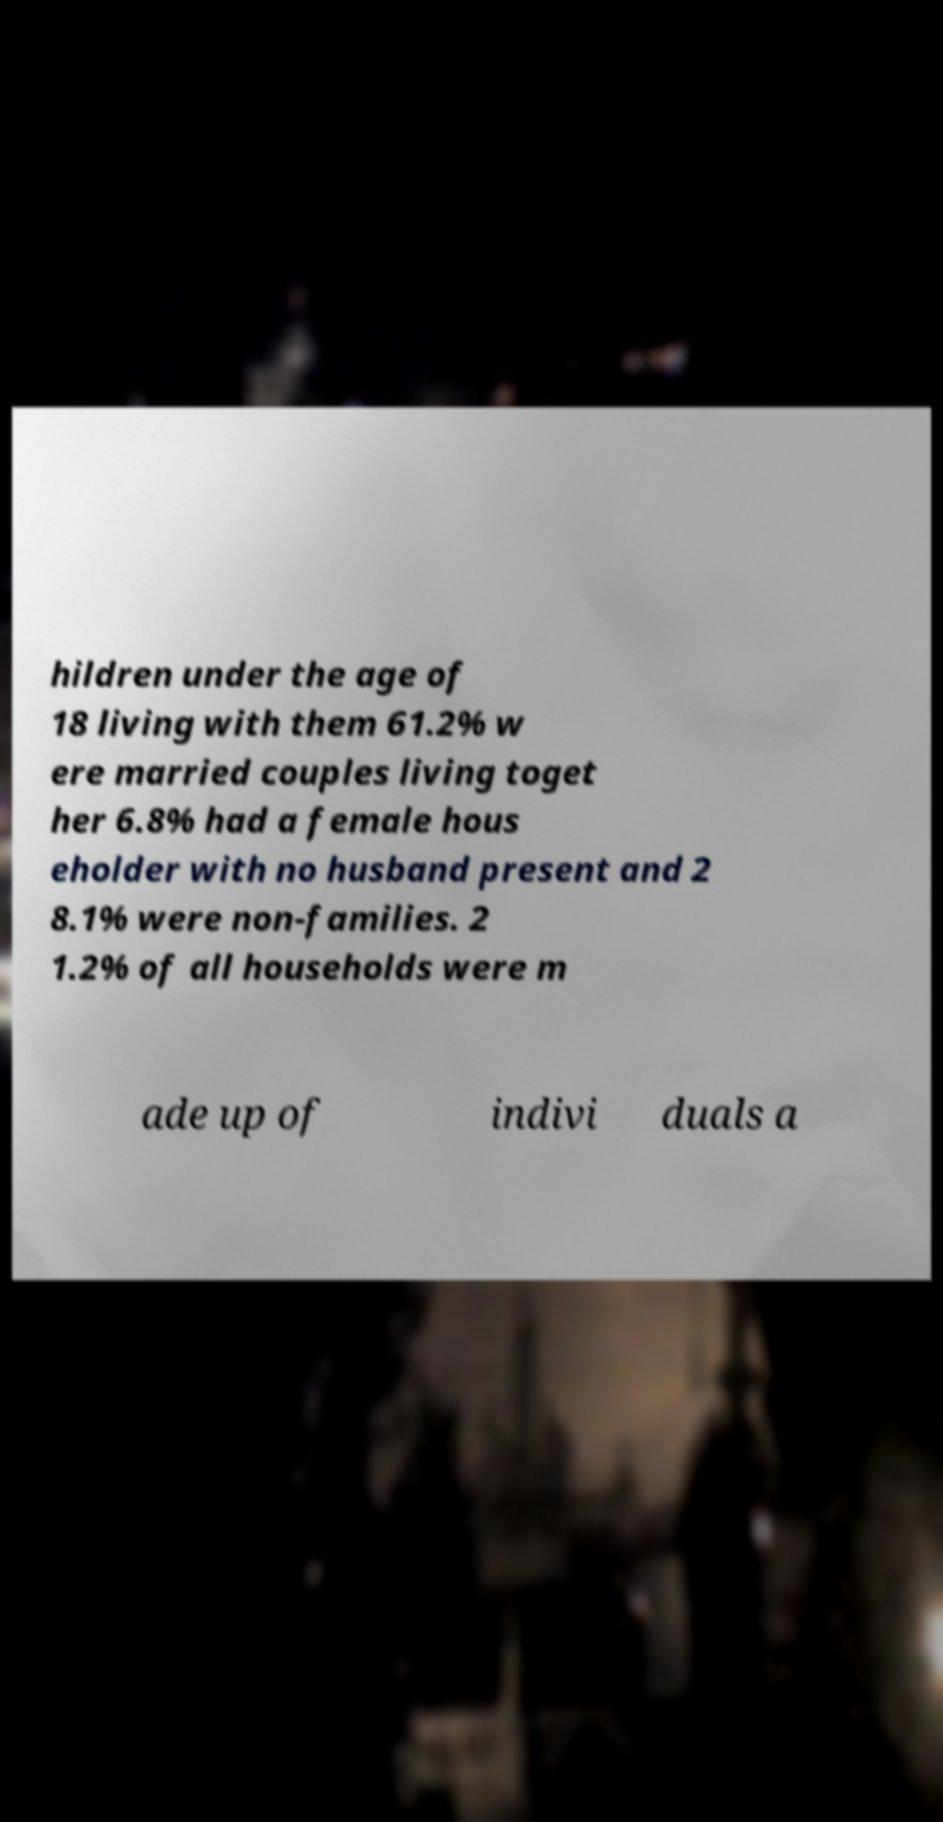Can you read and provide the text displayed in the image?This photo seems to have some interesting text. Can you extract and type it out for me? hildren under the age of 18 living with them 61.2% w ere married couples living toget her 6.8% had a female hous eholder with no husband present and 2 8.1% were non-families. 2 1.2% of all households were m ade up of indivi duals a 